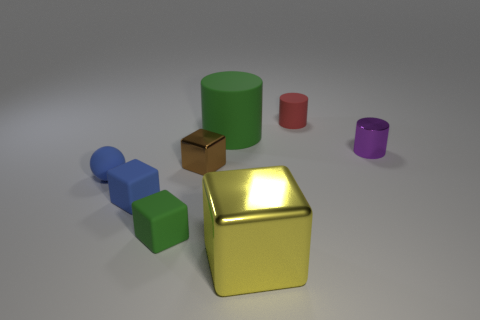Subtract 2 cubes. How many cubes are left? 2 Subtract all rubber cylinders. How many cylinders are left? 1 Subtract all gray blocks. Subtract all purple balls. How many blocks are left? 4 Add 2 green metallic blocks. How many objects exist? 10 Subtract all cylinders. How many objects are left? 5 Subtract 0 gray balls. How many objects are left? 8 Subtract all big green cylinders. Subtract all red cylinders. How many objects are left? 6 Add 6 small brown metal blocks. How many small brown metal blocks are left? 7 Add 1 red matte cylinders. How many red matte cylinders exist? 2 